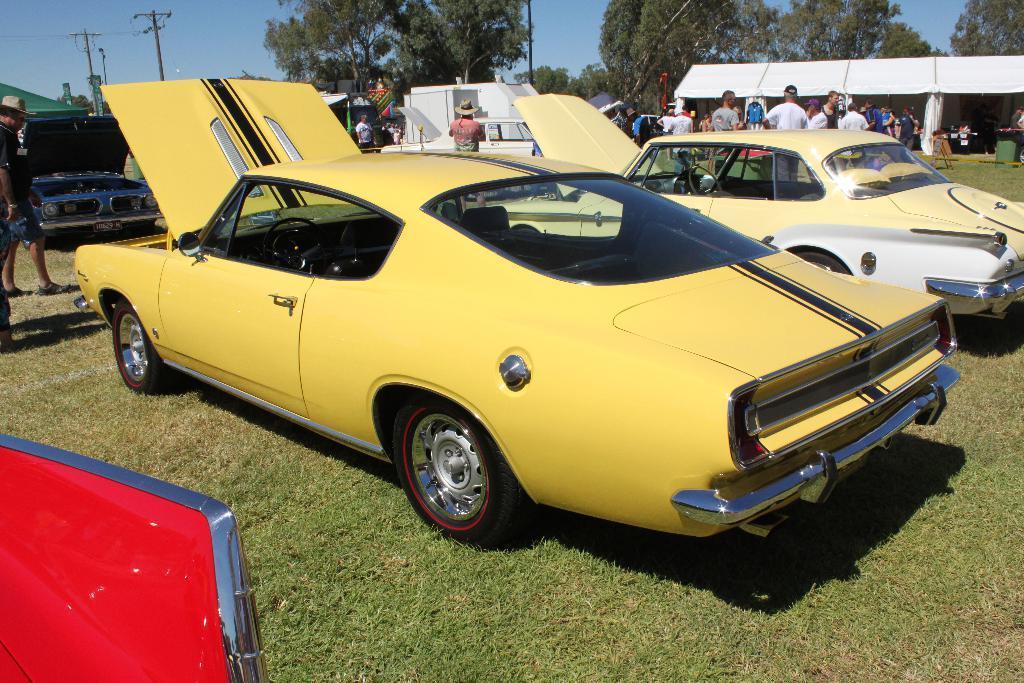Describe this image in one or two sentences. This picture shows few cars parked and we see few people standing and couple of them wore hats on their heads and we see all the car bonnets are opened and we see trees and couple of electrical poles and we see tents on the side and a blue sky and we see grass on the ground. 